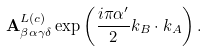<formula> <loc_0><loc_0><loc_500><loc_500>\mathbf A _ { \beta \alpha \gamma \delta } ^ { L ( c ) } \exp \left ( \frac { i \pi \alpha ^ { \prime } } { 2 } k _ { B } \cdot k _ { A } \right ) .</formula> 